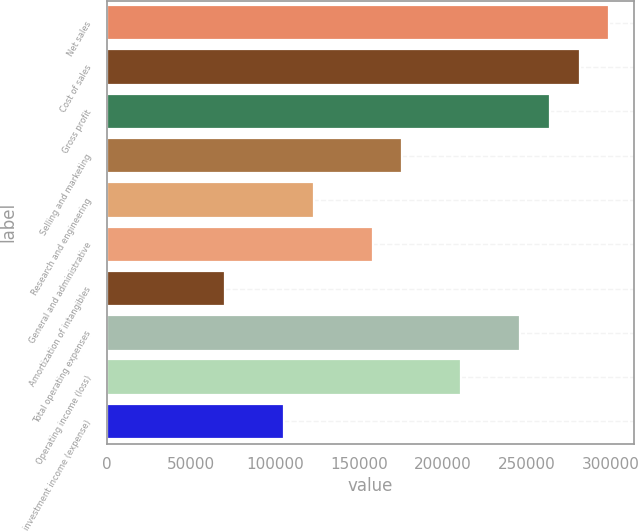Convert chart to OTSL. <chart><loc_0><loc_0><loc_500><loc_500><bar_chart><fcel>Net sales<fcel>Cost of sales<fcel>Gross profit<fcel>Selling and marketing<fcel>Research and engineering<fcel>General and administrative<fcel>Amortization of intangibles<fcel>Total operating expenses<fcel>Operating income (loss)<fcel>investment income (expense)<nl><fcel>298883<fcel>281302<fcel>263721<fcel>175814<fcel>123070<fcel>158233<fcel>70325.8<fcel>246139<fcel>210977<fcel>105489<nl></chart> 